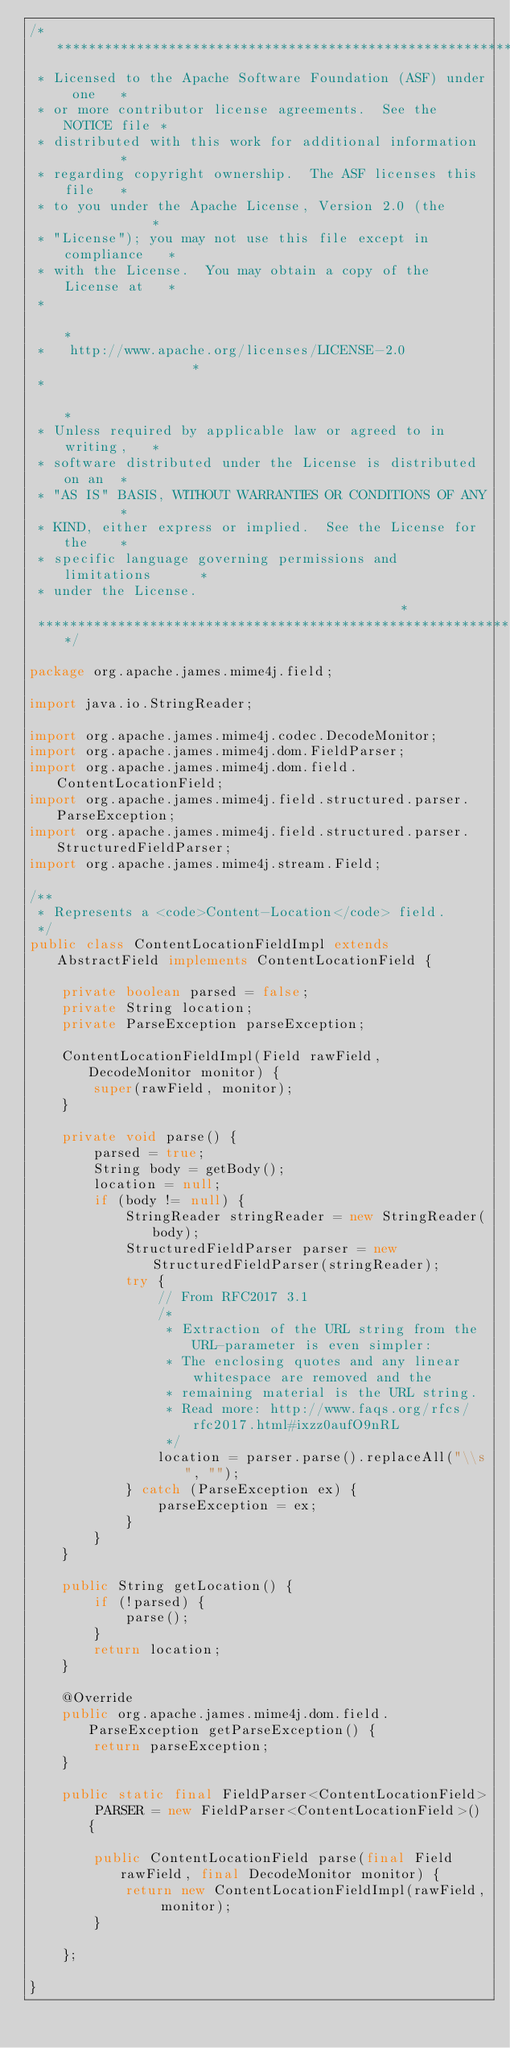Convert code to text. <code><loc_0><loc_0><loc_500><loc_500><_Java_>/****************************************************************
 * Licensed to the Apache Software Foundation (ASF) under one   *
 * or more contributor license agreements.  See the NOTICE file *
 * distributed with this work for additional information        *
 * regarding copyright ownership.  The ASF licenses this file   *
 * to you under the Apache License, Version 2.0 (the            *
 * "License"); you may not use this file except in compliance   *
 * with the License.  You may obtain a copy of the License at   *
 *                                                              *
 *   http://www.apache.org/licenses/LICENSE-2.0                 *
 *                                                              *
 * Unless required by applicable law or agreed to in writing,   *
 * software distributed under the License is distributed on an  *
 * "AS IS" BASIS, WITHOUT WARRANTIES OR CONDITIONS OF ANY       *
 * KIND, either express or implied.  See the License for the    *
 * specific language governing permissions and limitations      *
 * under the License.                                           *
 ****************************************************************/

package org.apache.james.mime4j.field;

import java.io.StringReader;

import org.apache.james.mime4j.codec.DecodeMonitor;
import org.apache.james.mime4j.dom.FieldParser;
import org.apache.james.mime4j.dom.field.ContentLocationField;
import org.apache.james.mime4j.field.structured.parser.ParseException;
import org.apache.james.mime4j.field.structured.parser.StructuredFieldParser;
import org.apache.james.mime4j.stream.Field;

/**
 * Represents a <code>Content-Location</code> field.
 */
public class ContentLocationFieldImpl extends AbstractField implements ContentLocationField {

    private boolean parsed = false;
    private String location;
    private ParseException parseException;

    ContentLocationFieldImpl(Field rawField, DecodeMonitor monitor) {
        super(rawField, monitor);
    }

    private void parse() {
        parsed = true;
        String body = getBody();
        location = null;
        if (body != null) {
            StringReader stringReader = new StringReader(body);
            StructuredFieldParser parser = new StructuredFieldParser(stringReader);
            try {
                // From RFC2017 3.1
                /*
                 * Extraction of the URL string from the URL-parameter is even simpler:
                 * The enclosing quotes and any linear whitespace are removed and the
                 * remaining material is the URL string.
                 * Read more: http://www.faqs.org/rfcs/rfc2017.html#ixzz0aufO9nRL
                 */
                location = parser.parse().replaceAll("\\s", "");
            } catch (ParseException ex) {
                parseException = ex;
            }
        }
    }

    public String getLocation() {
        if (!parsed) {
            parse();
        }
        return location;
    }

    @Override
    public org.apache.james.mime4j.dom.field.ParseException getParseException() {
        return parseException;
    }

    public static final FieldParser<ContentLocationField> PARSER = new FieldParser<ContentLocationField>() {

        public ContentLocationField parse(final Field rawField, final DecodeMonitor monitor) {
            return new ContentLocationFieldImpl(rawField, monitor);
        }

    };

}

</code> 